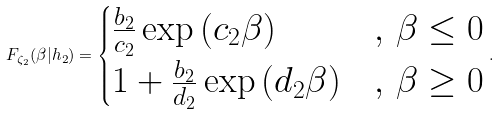Convert formula to latex. <formula><loc_0><loc_0><loc_500><loc_500>F _ { \zeta _ { 2 } } ( \beta | h _ { 2 } ) = \begin{cases} \frac { b _ { 2 } } { c _ { 2 } } \exp \left ( c _ { 2 } \beta \right ) & , \, \beta \leq 0 \\ 1 + \frac { b _ { 2 } } { d _ { 2 } } \exp \left ( d _ { 2 } \beta \right ) & , \, \beta \geq 0 \end{cases} .</formula> 